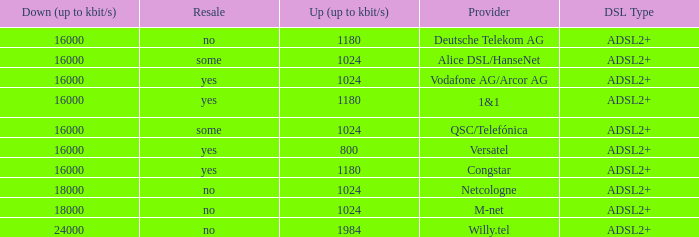What are all the dsl type offered by the M-Net telecom company? ADSL2+. Can you give me this table as a dict? {'header': ['Down (up to kbit/s)', 'Resale', 'Up (up to kbit/s)', 'Provider', 'DSL Type'], 'rows': [['16000', 'no', '1180', 'Deutsche Telekom AG', 'ADSL2+'], ['16000', 'some', '1024', 'Alice DSL/HanseNet', 'ADSL2+'], ['16000', 'yes', '1024', 'Vodafone AG/Arcor AG', 'ADSL2+'], ['16000', 'yes', '1180', '1&1', 'ADSL2+'], ['16000', 'some', '1024', 'QSC/Telefónica', 'ADSL2+'], ['16000', 'yes', '800', 'Versatel', 'ADSL2+'], ['16000', 'yes', '1180', 'Congstar', 'ADSL2+'], ['18000', 'no', '1024', 'Netcologne', 'ADSL2+'], ['18000', 'no', '1024', 'M-net', 'ADSL2+'], ['24000', 'no', '1984', 'Willy.tel', 'ADSL2+']]} 